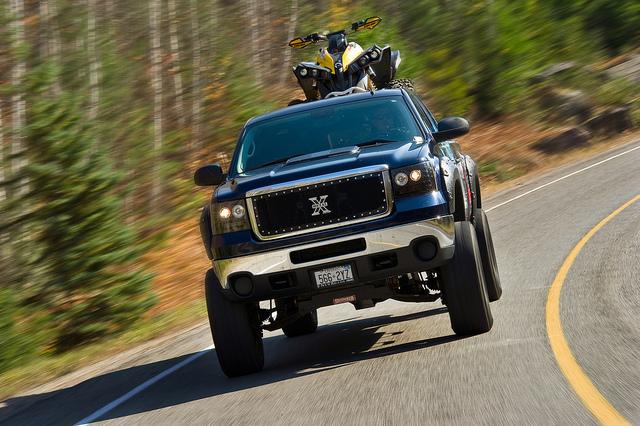What is on top of the truck?
Concise answer only. Atv. Which type of car is this?
Give a very brief answer. Truck. Is the truck being driven fast?
Concise answer only. Yes. 